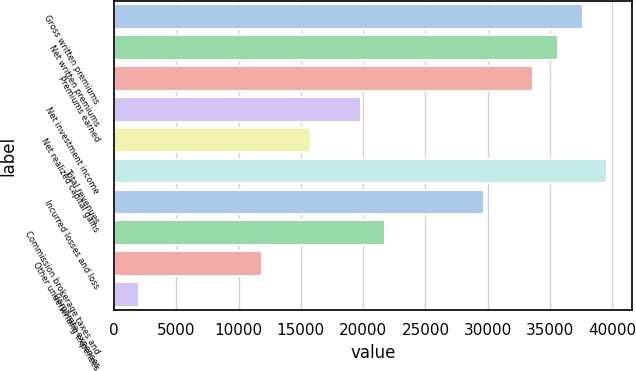<chart> <loc_0><loc_0><loc_500><loc_500><bar_chart><fcel>Gross written premiums<fcel>Net written premiums<fcel>Premiums earned<fcel>Net investment income<fcel>Net realized capital gains<fcel>Total revenues<fcel>Incurred losses and loss<fcel>Commission brokerage taxes and<fcel>Other underwriting expenses<fcel>Corporate expenses<nl><fcel>37616.7<fcel>35637.9<fcel>33659.2<fcel>19808<fcel>15850.5<fcel>39595.4<fcel>29701.7<fcel>21786.7<fcel>11893<fcel>1999.34<nl></chart> 